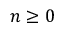Convert formula to latex. <formula><loc_0><loc_0><loc_500><loc_500>n \geq 0</formula> 